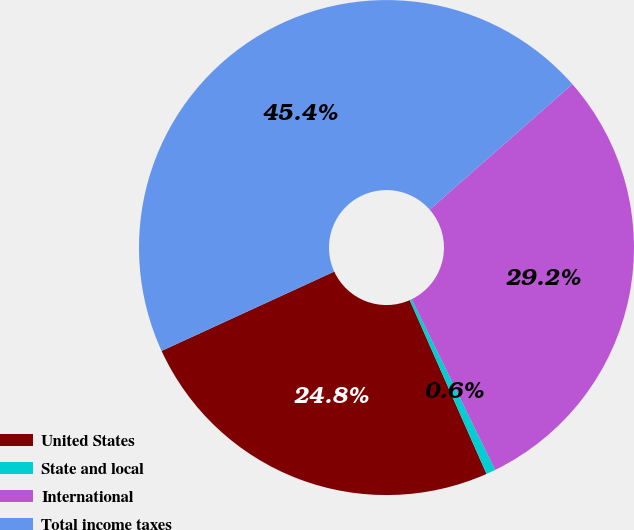Convert chart. <chart><loc_0><loc_0><loc_500><loc_500><pie_chart><fcel>United States<fcel>State and local<fcel>International<fcel>Total income taxes<nl><fcel>24.77%<fcel>0.61%<fcel>29.24%<fcel>45.38%<nl></chart> 